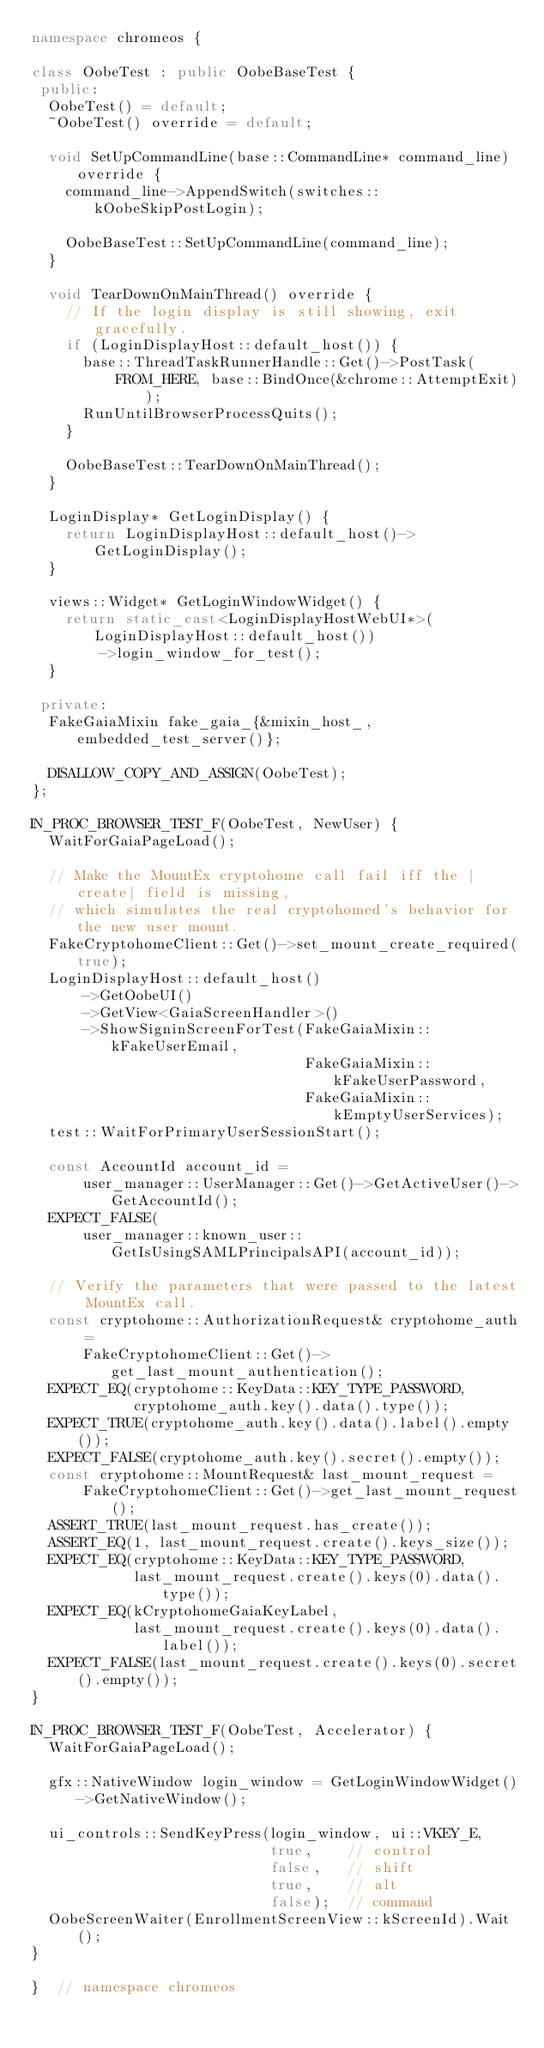<code> <loc_0><loc_0><loc_500><loc_500><_C++_>namespace chromeos {

class OobeTest : public OobeBaseTest {
 public:
  OobeTest() = default;
  ~OobeTest() override = default;

  void SetUpCommandLine(base::CommandLine* command_line) override {
    command_line->AppendSwitch(switches::kOobeSkipPostLogin);

    OobeBaseTest::SetUpCommandLine(command_line);
  }

  void TearDownOnMainThread() override {
    // If the login display is still showing, exit gracefully.
    if (LoginDisplayHost::default_host()) {
      base::ThreadTaskRunnerHandle::Get()->PostTask(
          FROM_HERE, base::BindOnce(&chrome::AttemptExit));
      RunUntilBrowserProcessQuits();
    }

    OobeBaseTest::TearDownOnMainThread();
  }

  LoginDisplay* GetLoginDisplay() {
    return LoginDisplayHost::default_host()->GetLoginDisplay();
  }

  views::Widget* GetLoginWindowWidget() {
    return static_cast<LoginDisplayHostWebUI*>(LoginDisplayHost::default_host())
        ->login_window_for_test();
  }

 private:
  FakeGaiaMixin fake_gaia_{&mixin_host_, embedded_test_server()};

  DISALLOW_COPY_AND_ASSIGN(OobeTest);
};

IN_PROC_BROWSER_TEST_F(OobeTest, NewUser) {
  WaitForGaiaPageLoad();

  // Make the MountEx cryptohome call fail iff the |create| field is missing,
  // which simulates the real cryptohomed's behavior for the new user mount.
  FakeCryptohomeClient::Get()->set_mount_create_required(true);
  LoginDisplayHost::default_host()
      ->GetOobeUI()
      ->GetView<GaiaScreenHandler>()
      ->ShowSigninScreenForTest(FakeGaiaMixin::kFakeUserEmail,
                                FakeGaiaMixin::kFakeUserPassword,
                                FakeGaiaMixin::kEmptyUserServices);
  test::WaitForPrimaryUserSessionStart();

  const AccountId account_id =
      user_manager::UserManager::Get()->GetActiveUser()->GetAccountId();
  EXPECT_FALSE(
      user_manager::known_user::GetIsUsingSAMLPrincipalsAPI(account_id));

  // Verify the parameters that were passed to the latest MountEx call.
  const cryptohome::AuthorizationRequest& cryptohome_auth =
      FakeCryptohomeClient::Get()->get_last_mount_authentication();
  EXPECT_EQ(cryptohome::KeyData::KEY_TYPE_PASSWORD,
            cryptohome_auth.key().data().type());
  EXPECT_TRUE(cryptohome_auth.key().data().label().empty());
  EXPECT_FALSE(cryptohome_auth.key().secret().empty());
  const cryptohome::MountRequest& last_mount_request =
      FakeCryptohomeClient::Get()->get_last_mount_request();
  ASSERT_TRUE(last_mount_request.has_create());
  ASSERT_EQ(1, last_mount_request.create().keys_size());
  EXPECT_EQ(cryptohome::KeyData::KEY_TYPE_PASSWORD,
            last_mount_request.create().keys(0).data().type());
  EXPECT_EQ(kCryptohomeGaiaKeyLabel,
            last_mount_request.create().keys(0).data().label());
  EXPECT_FALSE(last_mount_request.create().keys(0).secret().empty());
}

IN_PROC_BROWSER_TEST_F(OobeTest, Accelerator) {
  WaitForGaiaPageLoad();

  gfx::NativeWindow login_window = GetLoginWindowWidget()->GetNativeWindow();

  ui_controls::SendKeyPress(login_window, ui::VKEY_E,
                            true,    // control
                            false,   // shift
                            true,    // alt
                            false);  // command
  OobeScreenWaiter(EnrollmentScreenView::kScreenId).Wait();
}

}  // namespace chromeos
</code> 